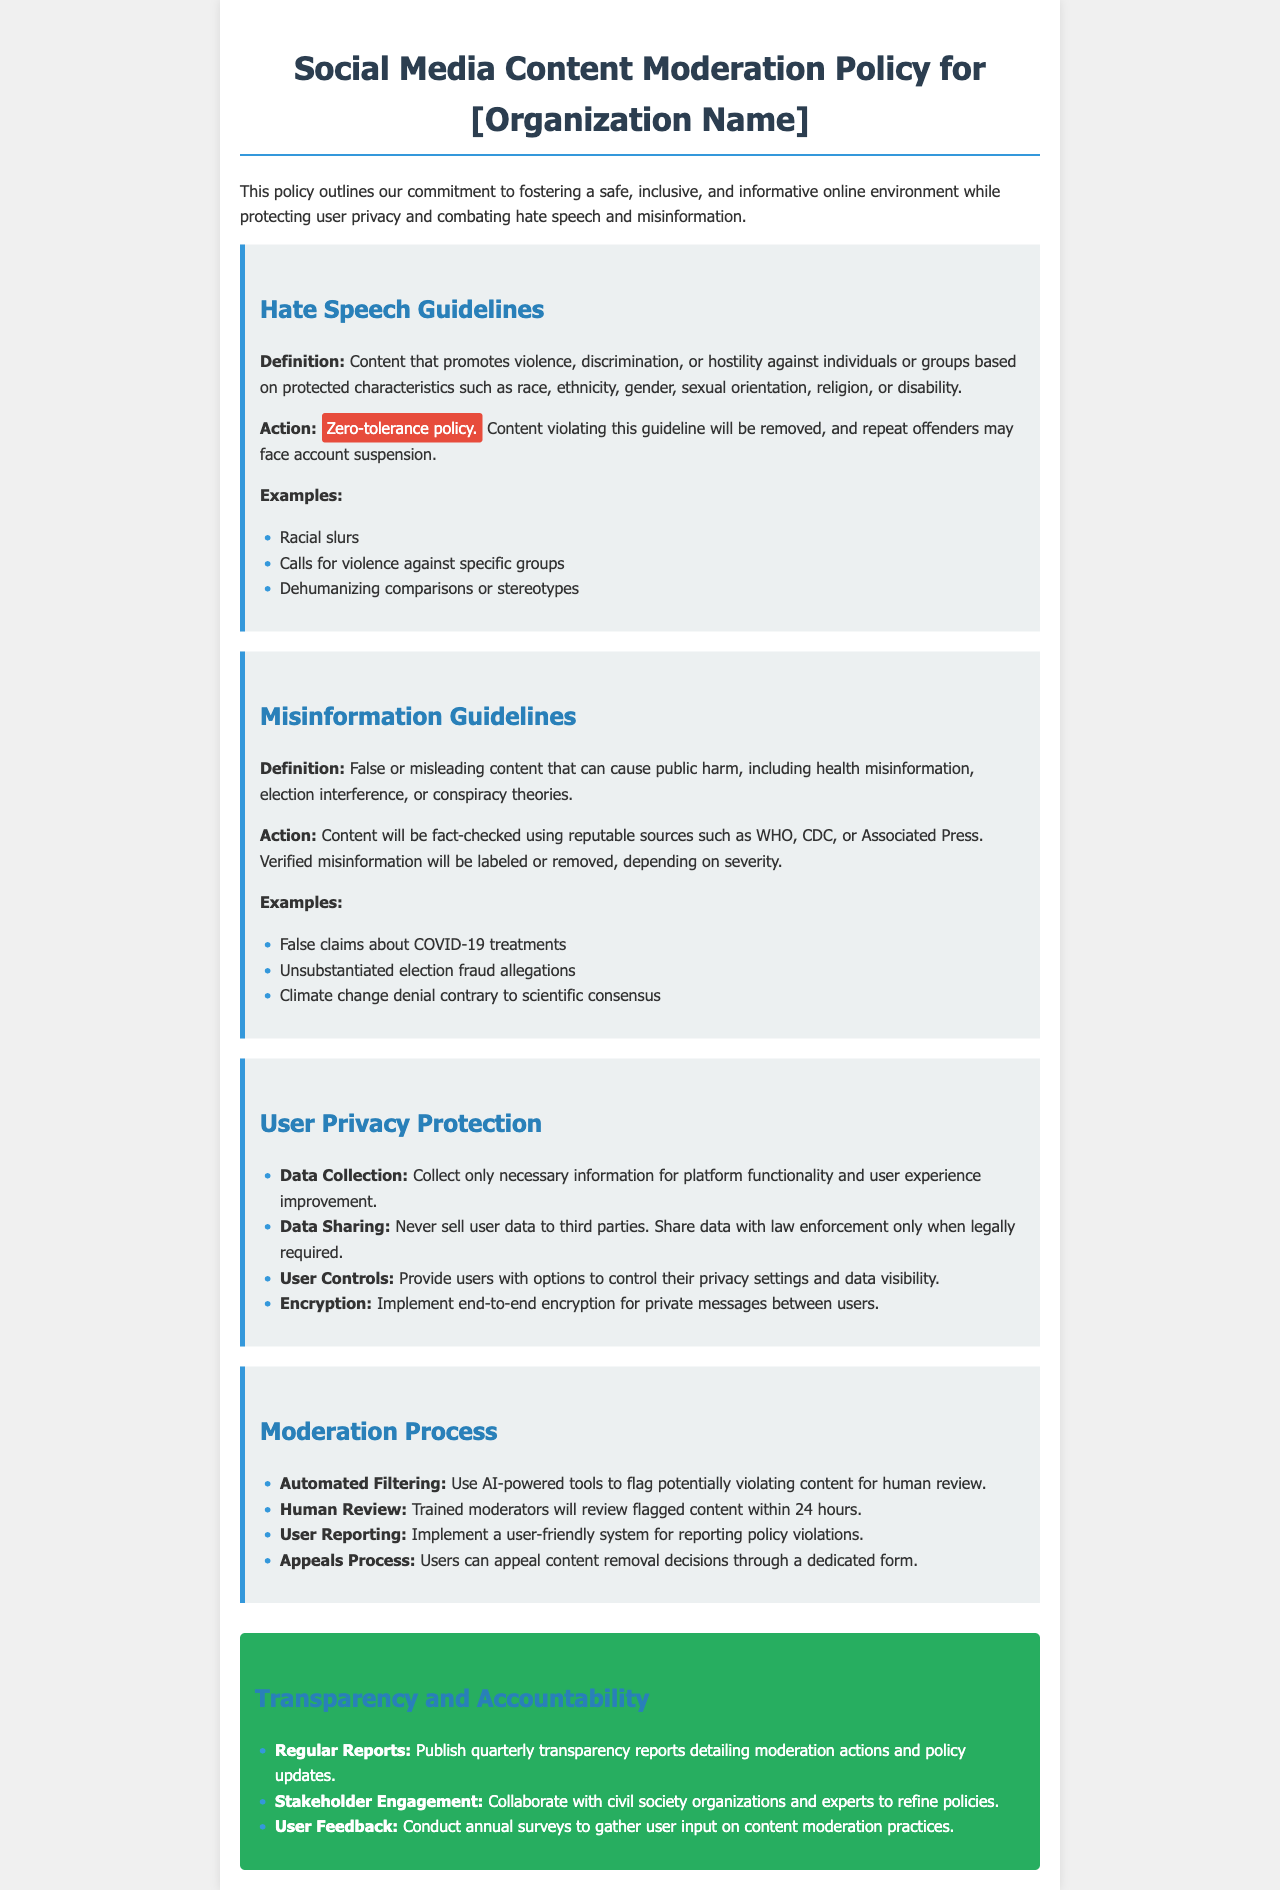What is the definition of hate speech? The definition of hate speech is content that promotes violence, discrimination, or hostility against individuals or groups based on protected characteristics.
Answer: Promotes violence, discrimination, or hostility What is the action for violating hate speech guidelines? The action for violating hate speech guidelines is outlined as a zero-tolerance policy where content will be removed and repeat offenders may face account suspension.
Answer: Zero-tolerance policy How is misinformation verified according to the guidelines? Misinformation is verified using reputable sources such as WHO, CDC, or Associated Press.
Answer: Reputable sources What are users provided to control their privacy settings? Users are provided options to control their privacy settings and data visibility.
Answer: Options How long do moderators take to review flagged content? Moderators will review flagged content within 24 hours.
Answer: 24 hours Which guideline includes examples like "false claims about COVID-19 treatments"? This example is included under the misinformation guidelines.
Answer: Misinformation guidelines How often are transparency reports published? Transparency reports are published quarterly.
Answer: Quarterly What is the focus of the transparency and accountability section? The focus of the transparency and accountability section includes regular reports, stakeholder engagement, and user feedback.
Answer: Regular reports, stakeholder engagement, user feedback 